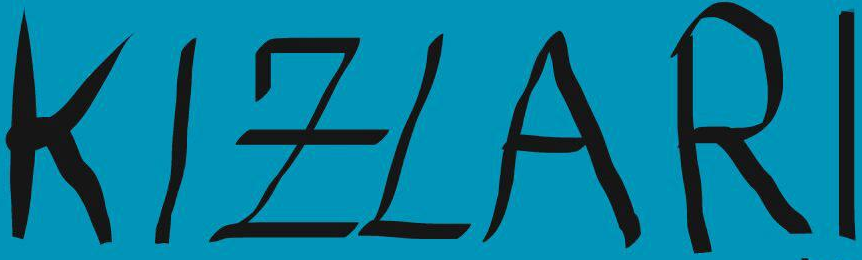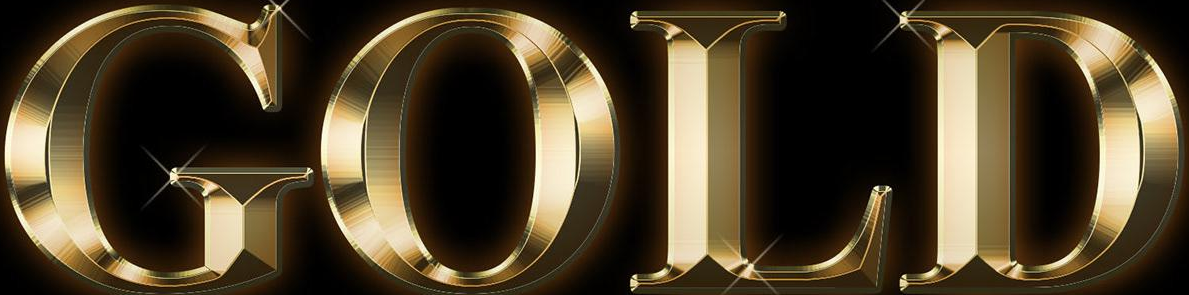Transcribe the words shown in these images in order, separated by a semicolon. KIZLARI; GOLD 